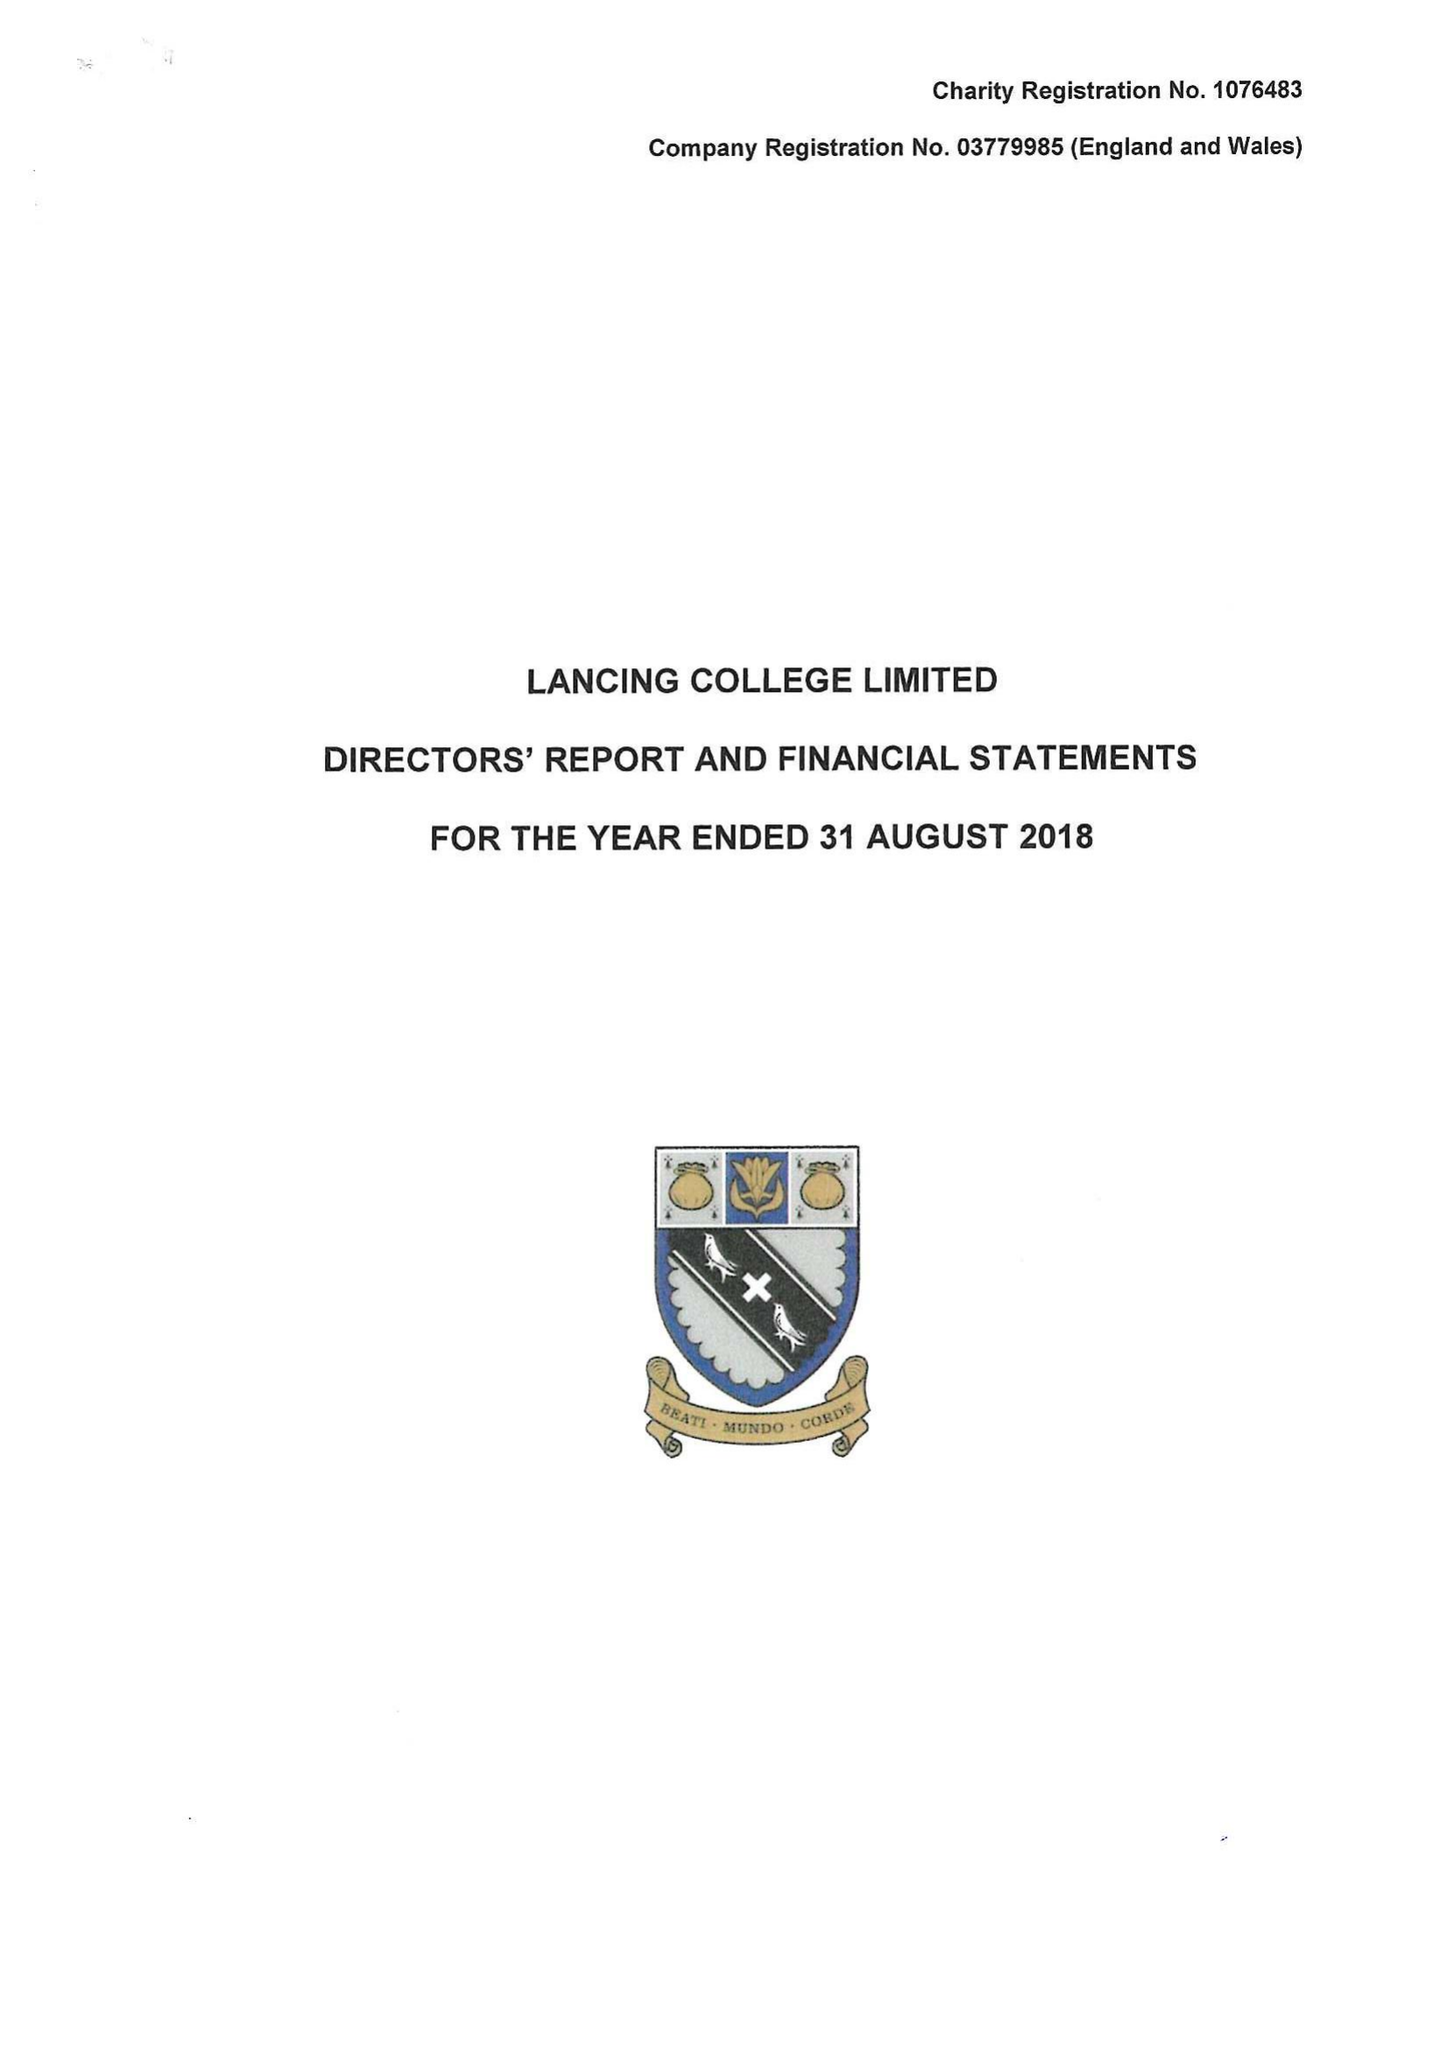What is the value for the report_date?
Answer the question using a single word or phrase. 2018-08-31 